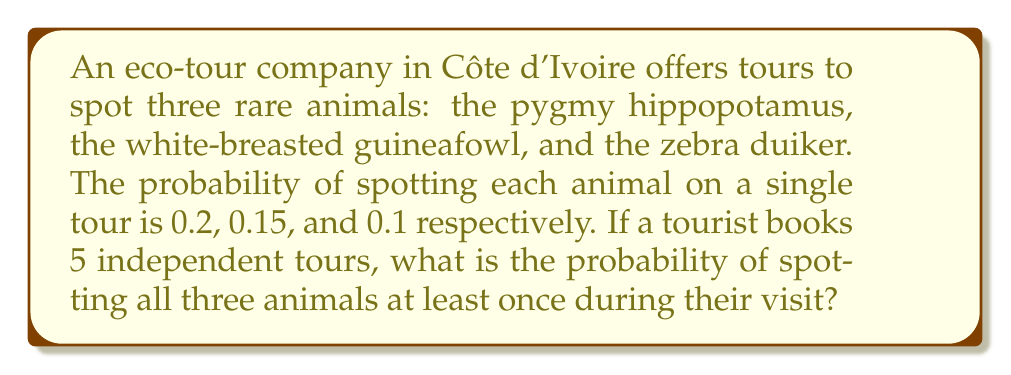Provide a solution to this math problem. Let's approach this step-by-step:

1) First, we need to calculate the probability of not spotting each animal on a single tour:
   - Pygmy hippopotamus: $1 - 0.2 = 0.8$
   - White-breasted guineafowl: $1 - 0.15 = 0.85$
   - Zebra duiker: $1 - 0.1 = 0.9$

2) Now, we calculate the probability of not spotting each animal in all 5 tours:
   - Pygmy hippopotamus: $0.8^5 = 0.32768$
   - White-breasted guineafowl: $0.85^5 \approx 0.44371$
   - Zebra duiker: $0.9^5 = 0.59049$

3) The probability of spotting each animal at least once is the complement of not spotting it at all:
   - Pygmy hippopotamus: $1 - 0.32768 = 0.67232$
   - White-breasted guineafowl: $1 - 0.44371 \approx 0.55629$
   - Zebra duiker: $1 - 0.59049 = 0.40951$

4) The probability of spotting all three animals at least once is the product of these individual probabilities:

   $$P(\text{all three}) = 0.67232 \times 0.55629 \times 0.40951 \approx 0.15321$$

5) Convert to a percentage: $0.15321 \times 100\% \approx 15.321\%$
Answer: $15.321\%$ 